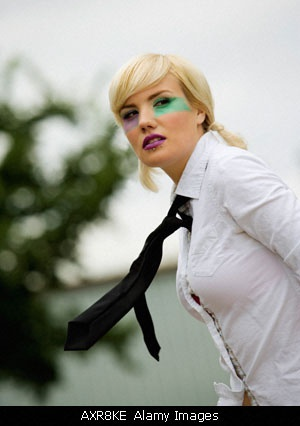Describe the objects in this image and their specific colors. I can see people in lightgray, darkgray, black, and tan tones and tie in lightgray, black, gray, and darkgray tones in this image. 